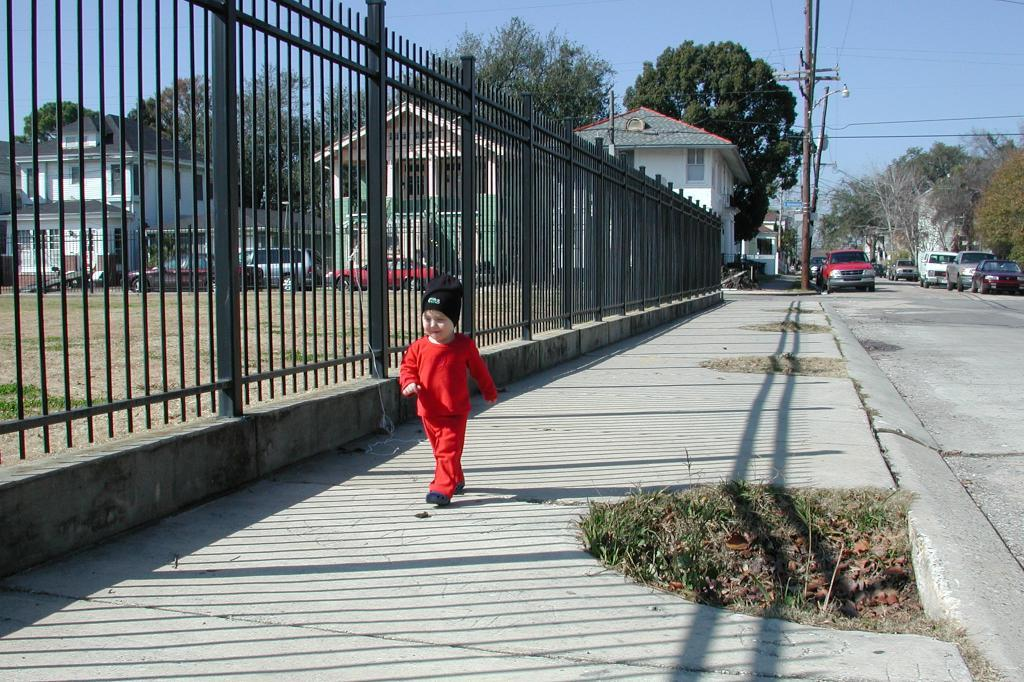What is the main subject in the foreground of the image? There is a child in the foreground of the image. What can be seen in the background of the image? There are houses, a boundary, trees, vehicles, wires, and the sky visible in the background of the image. What emotion is the child expressing in the image? The image does not provide any information about the child's emotions, so we cannot determine their emotional state from the image. 